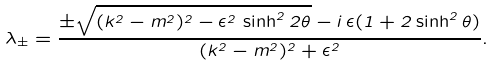Convert formula to latex. <formula><loc_0><loc_0><loc_500><loc_500>\lambda _ { \pm } = \frac { \pm \sqrt { ( k ^ { 2 } - m ^ { 2 } ) ^ { 2 } - \epsilon ^ { 2 } \, \sinh ^ { 2 } 2 \theta } - i \, \epsilon ( 1 + 2 \sinh ^ { 2 } \theta ) } { ( k ^ { 2 } - m ^ { 2 } ) ^ { 2 } + \epsilon ^ { 2 } } .</formula> 